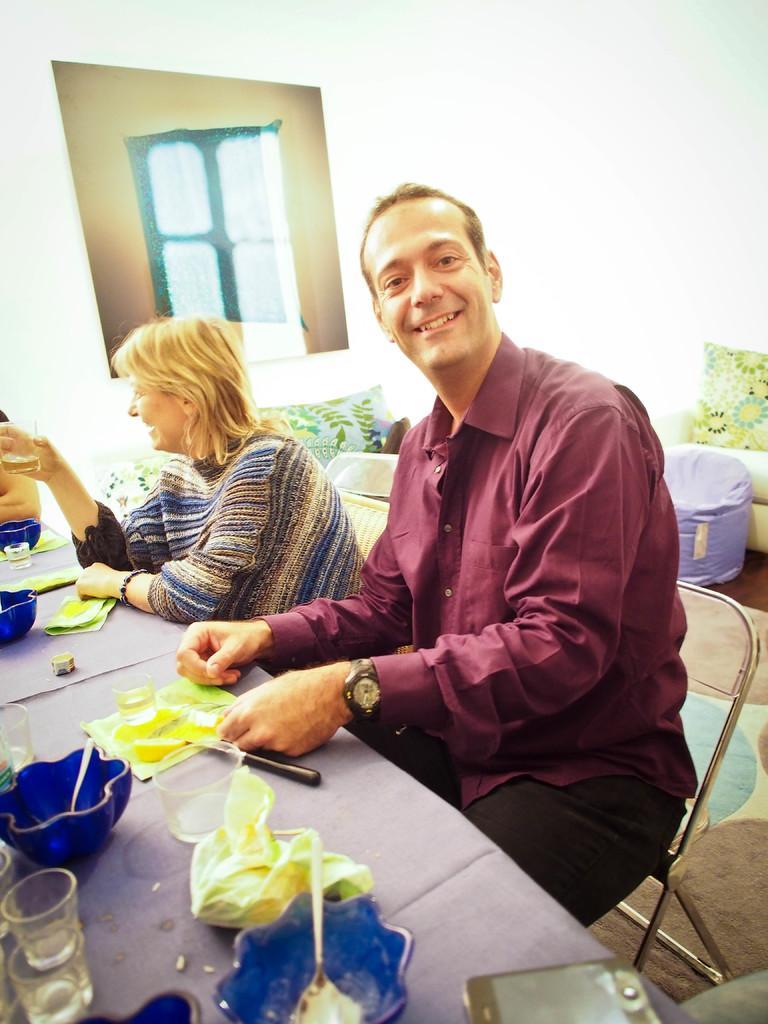Could you give a brief overview of what you see in this image? In the picture there are two persons a woman and a man, a man is smiling , both of them are sitting there is a table in front of them, the woman is speaking to someone else there are blue color bowls ,small glasses, spoon and a mobile on the table, behind them there is a sofa, in the background there is a white color wall and a photo frame. 